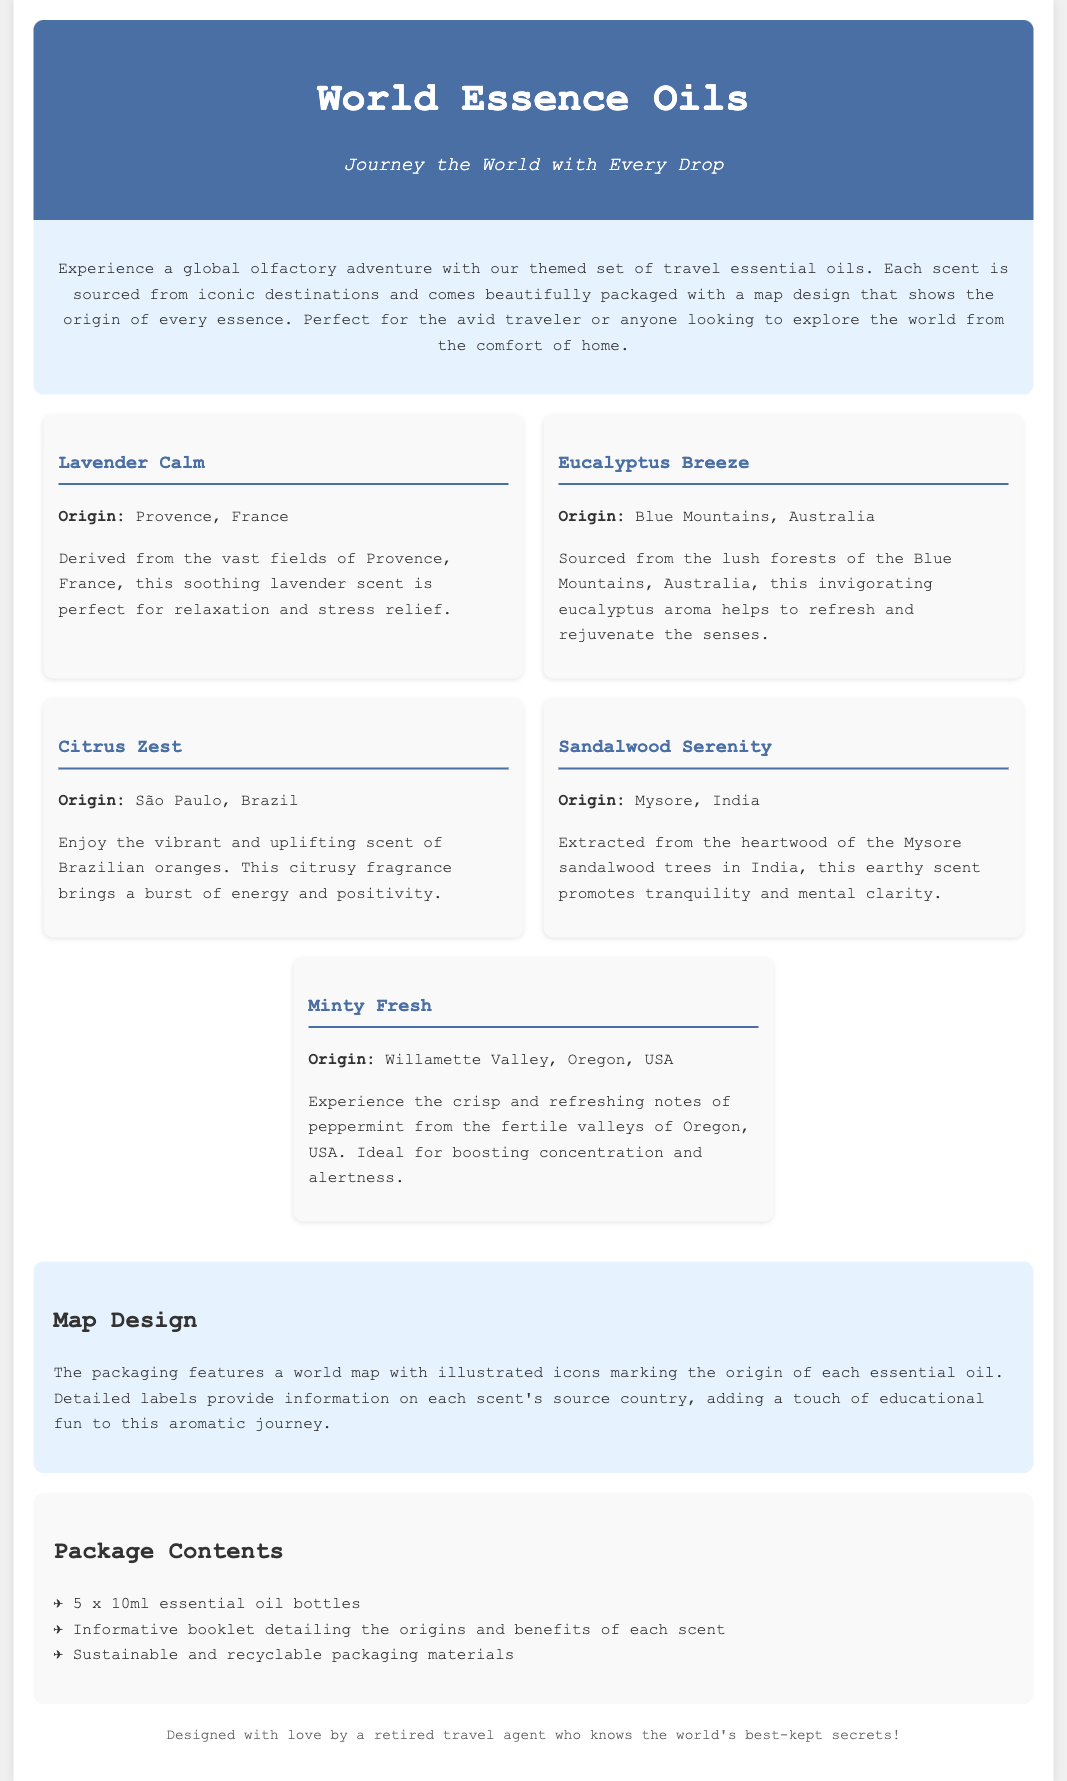What is the title of the product? The title of the product is found in the header section of the document, which is "World Essence Oils."
Answer: World Essence Oils What are the essential oil origins? Each essential oil has a specific origin listed in the document, including Provence, France; Blue Mountains, Australia; São Paulo, Brazil; Mysore, India; and Willamette Valley, Oregon, USA.
Answer: Provence, France; Blue Mountains, Australia; São Paulo, Brazil; Mysore, India; Willamette Valley, Oregon, USA What is the primary benefit of Lavender Calm? The document states that Lavender Calm is perfect for relaxation and stress relief.
Answer: Relaxation and stress relief How many essential oil bottles are included in the package? The package contents detail that there are 5 x 10ml essential oil bottles included.
Answer: 5 x 10ml What is the theme of the product packaging? The packaging has a theme that features a world map with illustrated icons marking the origins of each essential oil.
Answer: World map design Which scent is sourced from the Blue Mountains? The document specifies that Eucalyptus Breeze is the scent sourced from the Blue Mountains, Australia.
Answer: Eucalyptus Breeze Which product would likely help boost concentration? The document describes Minty Fresh as ideal for boosting concentration and alertness.
Answer: Minty Fresh What type of packaging materials are used? The package contents mention sustainable and recyclable packaging materials.
Answer: Sustainable and recyclable Who designed the product? The footer of the document attributes the design to a retired travel agent.
Answer: A retired travel agent 